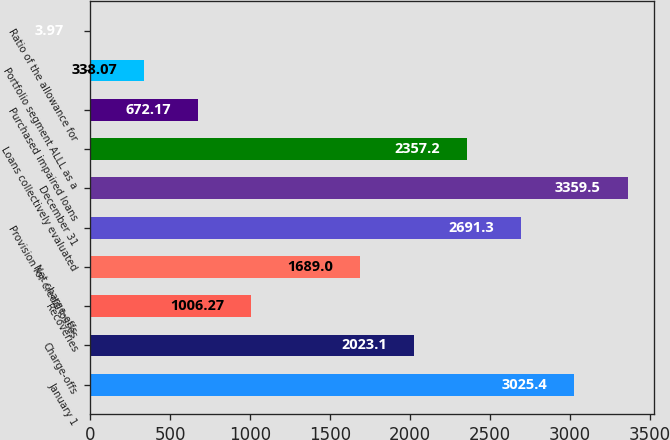Convert chart. <chart><loc_0><loc_0><loc_500><loc_500><bar_chart><fcel>January 1<fcel>Charge-offs<fcel>Recoveries<fcel>Net charge-offs<fcel>Provision for credit losses<fcel>December 31<fcel>Loans collectively evaluated<fcel>Purchased impaired loans<fcel>Portfolio segment ALLL as a<fcel>Ratio of the allowance for<nl><fcel>3025.4<fcel>2023.1<fcel>1006.27<fcel>1689<fcel>2691.3<fcel>3359.5<fcel>2357.2<fcel>672.17<fcel>338.07<fcel>3.97<nl></chart> 